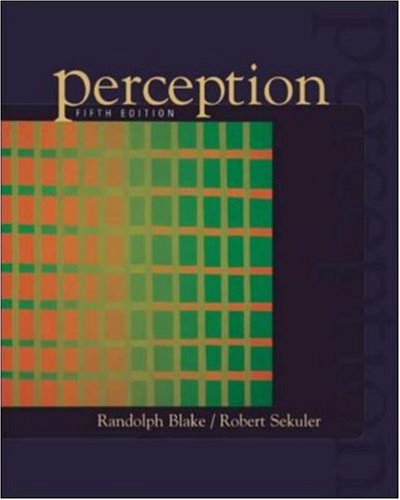Is this a pharmaceutical book? No, this is not a pharmaceutical book. 'Perception' primarily explores psychological and cognitive aspects of how we see and process visual information, not pharmaceutical topics. 